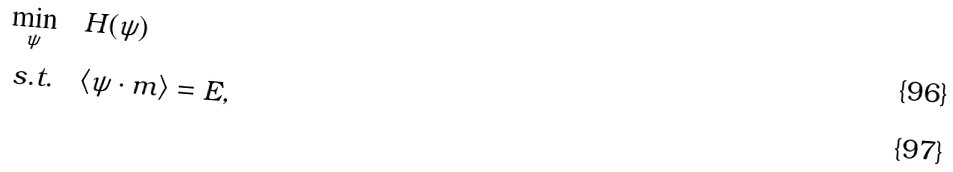<formula> <loc_0><loc_0><loc_500><loc_500>\underset { \psi } { \min } & \quad H ( \psi ) \\ \text {s.t.} & \quad \langle \psi \cdot m \rangle = E ,</formula> 